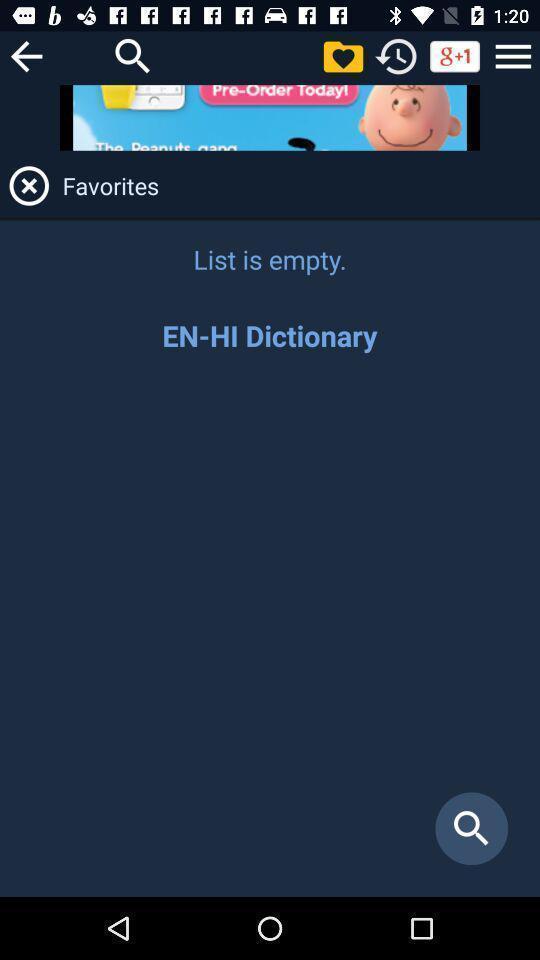Summarize the main components in this picture. Screen shows empty favorite list. 